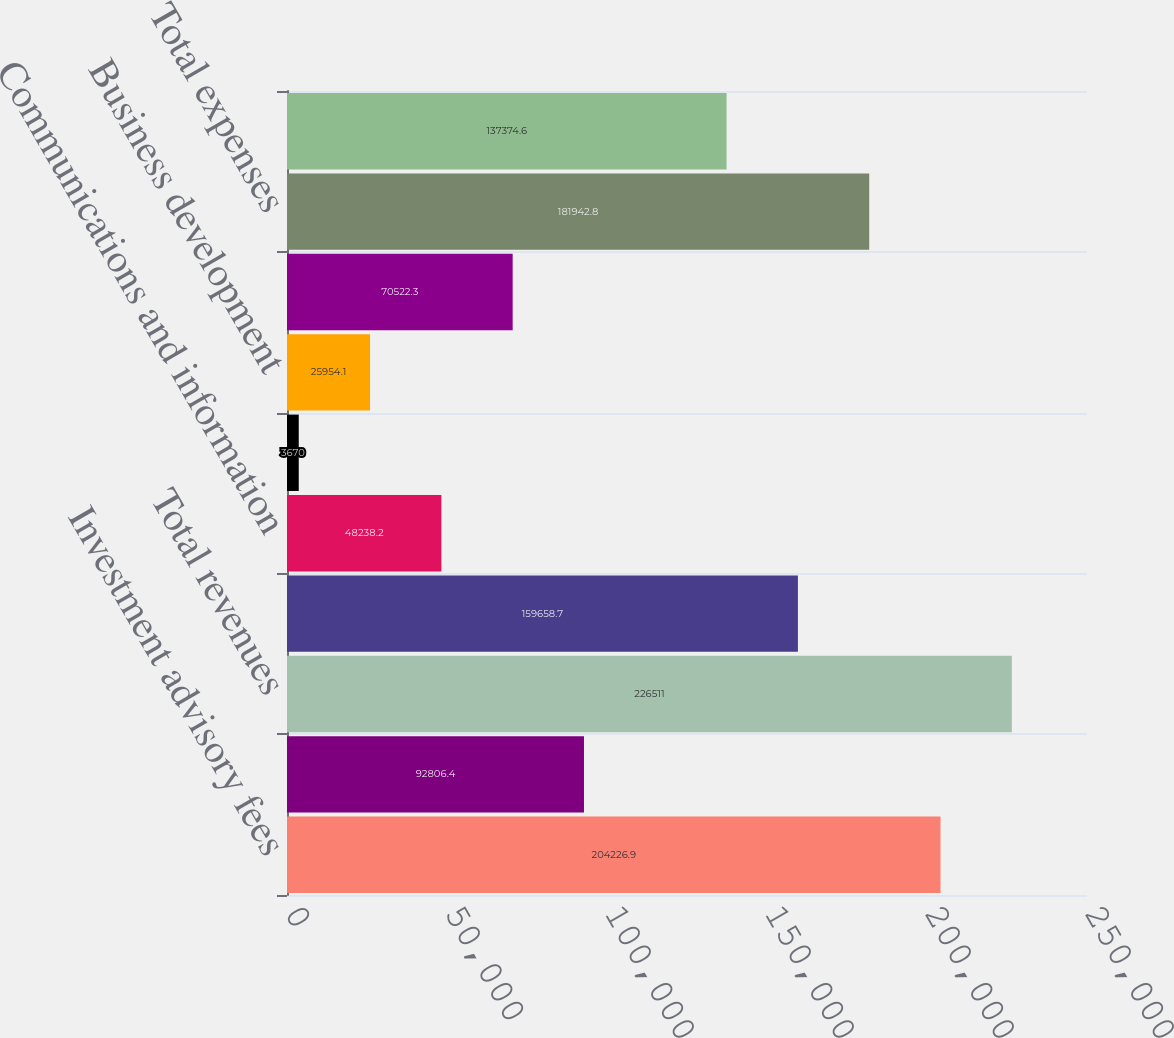<chart> <loc_0><loc_0><loc_500><loc_500><bar_chart><fcel>Investment advisory fees<fcel>Other<fcel>Total revenues<fcel>Admin & incentive compensation<fcel>Communications and information<fcel>Occupancy and equipment<fcel>Business development<fcel>Investment sub-advisory fees<fcel>Total expenses<fcel>Income before taxes and<nl><fcel>204227<fcel>92806.4<fcel>226511<fcel>159659<fcel>48238.2<fcel>3670<fcel>25954.1<fcel>70522.3<fcel>181943<fcel>137375<nl></chart> 